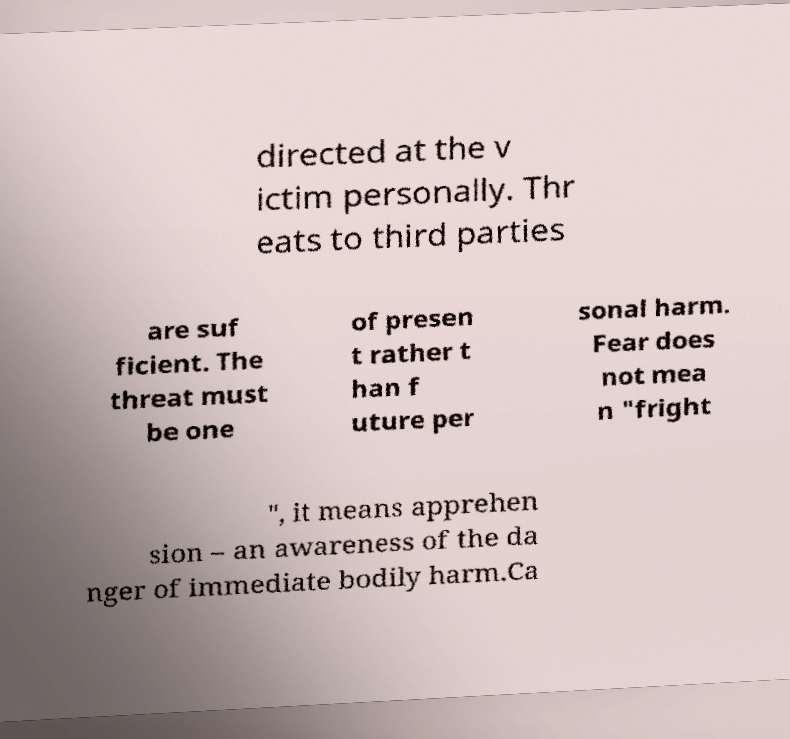Please read and relay the text visible in this image. What does it say? directed at the v ictim personally. Thr eats to third parties are suf ficient. The threat must be one of presen t rather t han f uture per sonal harm. Fear does not mea n "fright ", it means apprehen sion – an awareness of the da nger of immediate bodily harm.Ca 